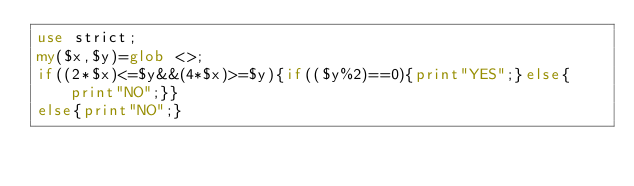<code> <loc_0><loc_0><loc_500><loc_500><_Perl_>use strict;
my($x,$y)=glob <>;
if((2*$x)<=$y&&(4*$x)>=$y){if(($y%2)==0){print"YES";}else{print"NO";}}
else{print"NO";}</code> 